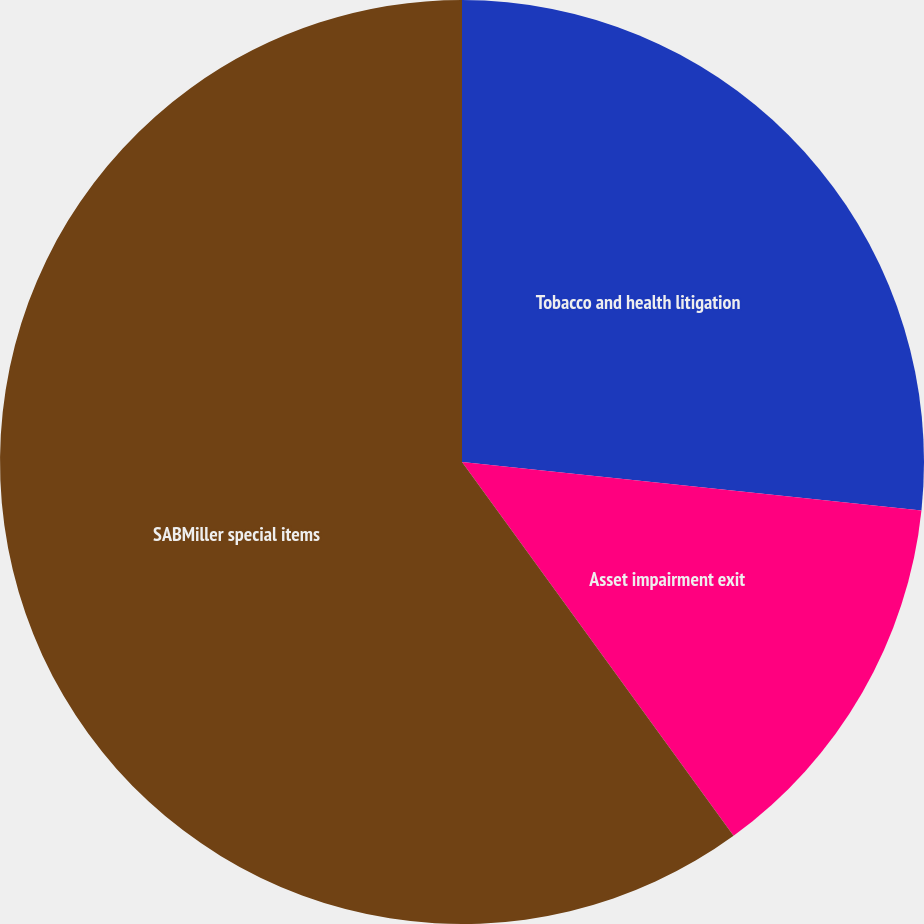<chart> <loc_0><loc_0><loc_500><loc_500><pie_chart><fcel>Tobacco and health litigation<fcel>Asset impairment exit<fcel>SABMiller special items<nl><fcel>26.67%<fcel>13.33%<fcel>60.0%<nl></chart> 